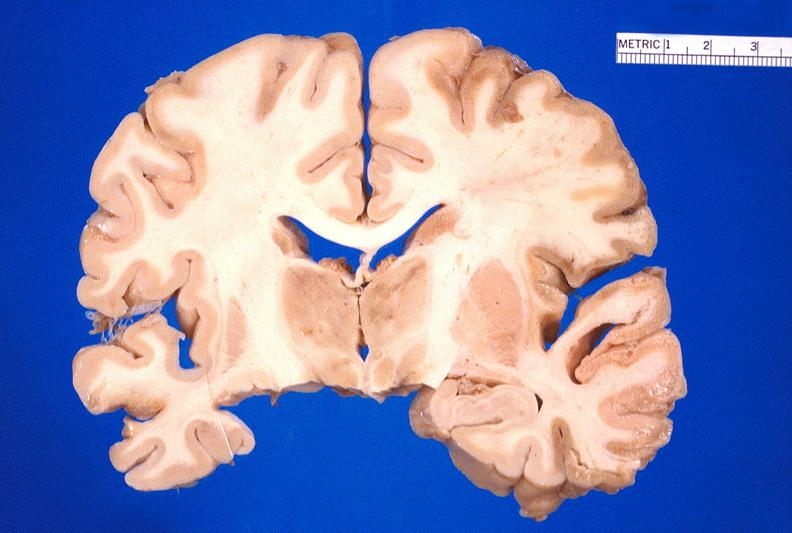does this image show brain, old infarcts, embolic?
Answer the question using a single word or phrase. Yes 